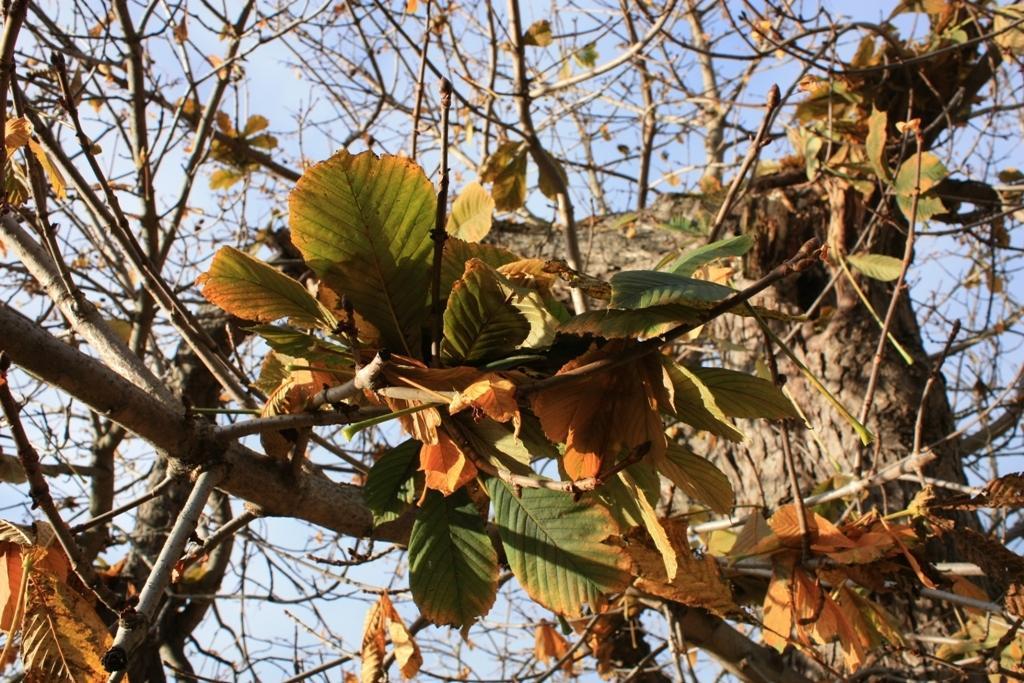In one or two sentences, can you explain what this image depicts? In the image there is a tree with branches and leaves. In the background there is a sky. 